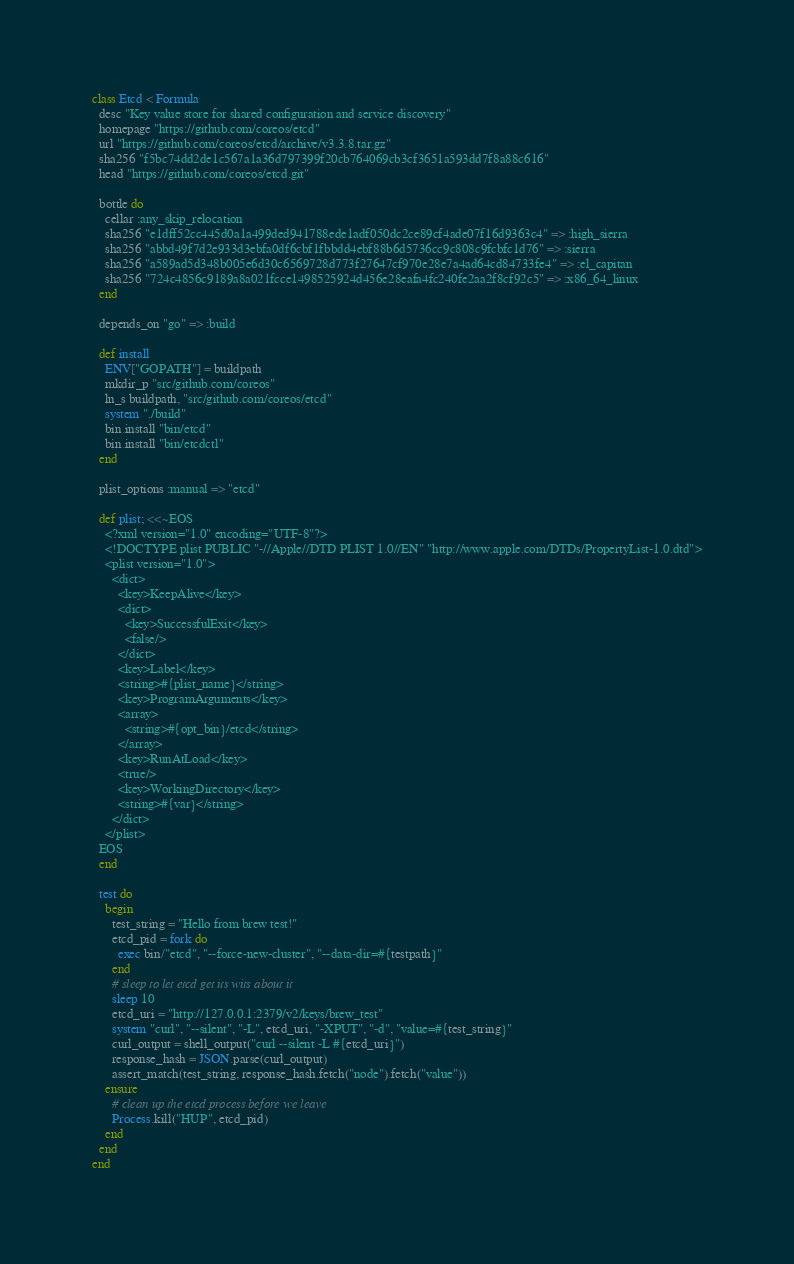Convert code to text. <code><loc_0><loc_0><loc_500><loc_500><_Ruby_>class Etcd < Formula
  desc "Key value store for shared configuration and service discovery"
  homepage "https://github.com/coreos/etcd"
  url "https://github.com/coreos/etcd/archive/v3.3.8.tar.gz"
  sha256 "f5bc74dd2de1c567a1a36d797399f20cb764069cb3cf3651a593dd7f8a88c616"
  head "https://github.com/coreos/etcd.git"

  bottle do
    cellar :any_skip_relocation
    sha256 "e1dff52cc445d0a1a499ded941788ede1adf050dc2ce89cf4ade07f16d9363c4" => :high_sierra
    sha256 "abbd49f7d2e933d3ebfa0df6cbf1fbbdd4ebf88b6d5736cc9c808c9fcbfc1d76" => :sierra
    sha256 "a589ad5d348b005e6d30c6569728d773f27647cf970e28e7a4ad64cd84733fe4" => :el_capitan
    sha256 "724c4856c9189a8a021fcce1498525924d456e28eafa4fc240fe2aa2f8cf92c5" => :x86_64_linux
  end

  depends_on "go" => :build

  def install
    ENV["GOPATH"] = buildpath
    mkdir_p "src/github.com/coreos"
    ln_s buildpath, "src/github.com/coreos/etcd"
    system "./build"
    bin.install "bin/etcd"
    bin.install "bin/etcdctl"
  end

  plist_options :manual => "etcd"

  def plist; <<~EOS
    <?xml version="1.0" encoding="UTF-8"?>
    <!DOCTYPE plist PUBLIC "-//Apple//DTD PLIST 1.0//EN" "http://www.apple.com/DTDs/PropertyList-1.0.dtd">
    <plist version="1.0">
      <dict>
        <key>KeepAlive</key>
        <dict>
          <key>SuccessfulExit</key>
          <false/>
        </dict>
        <key>Label</key>
        <string>#{plist_name}</string>
        <key>ProgramArguments</key>
        <array>
          <string>#{opt_bin}/etcd</string>
        </array>
        <key>RunAtLoad</key>
        <true/>
        <key>WorkingDirectory</key>
        <string>#{var}</string>
      </dict>
    </plist>
  EOS
  end

  test do
    begin
      test_string = "Hello from brew test!"
      etcd_pid = fork do
        exec bin/"etcd", "--force-new-cluster", "--data-dir=#{testpath}"
      end
      # sleep to let etcd get its wits about it
      sleep 10
      etcd_uri = "http://127.0.0.1:2379/v2/keys/brew_test"
      system "curl", "--silent", "-L", etcd_uri, "-XPUT", "-d", "value=#{test_string}"
      curl_output = shell_output("curl --silent -L #{etcd_uri}")
      response_hash = JSON.parse(curl_output)
      assert_match(test_string, response_hash.fetch("node").fetch("value"))
    ensure
      # clean up the etcd process before we leave
      Process.kill("HUP", etcd_pid)
    end
  end
end
</code> 